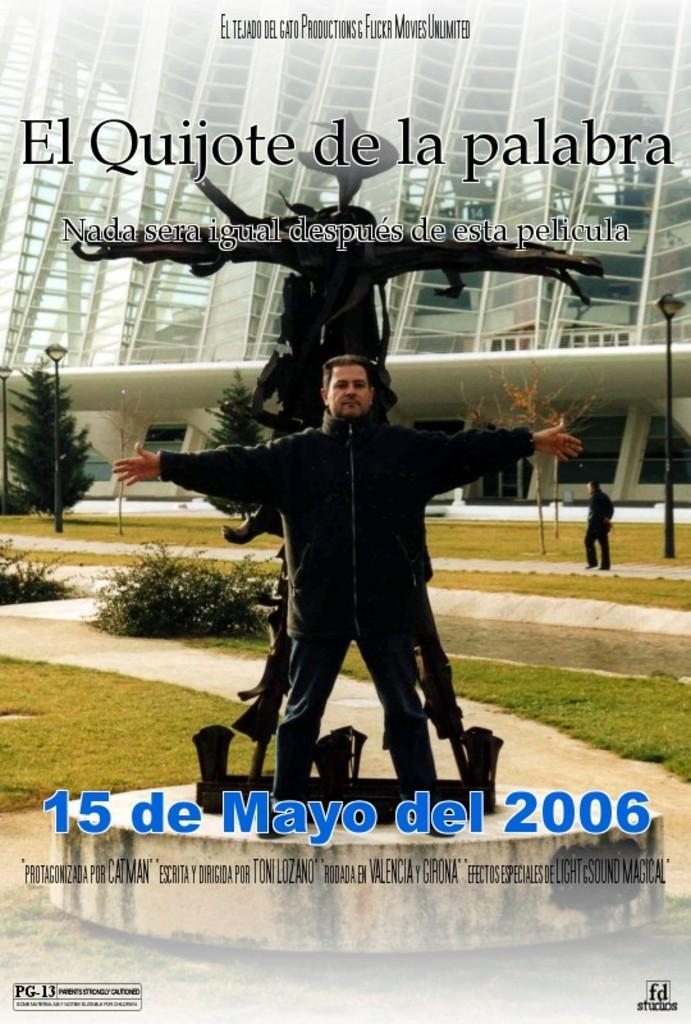<image>
Create a compact narrative representing the image presented. an ad about a movie entitled El Quijote de la palabra. 